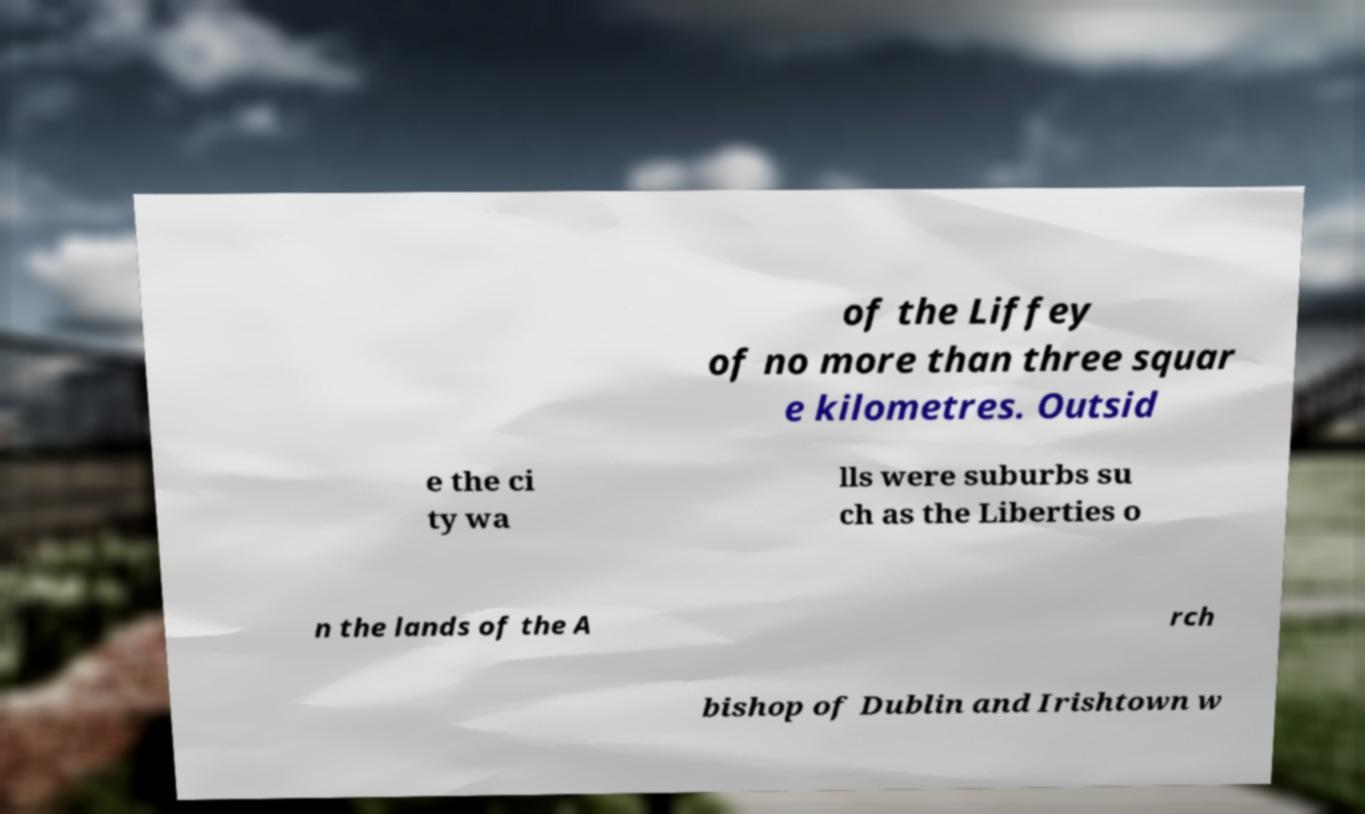I need the written content from this picture converted into text. Can you do that? of the Liffey of no more than three squar e kilometres. Outsid e the ci ty wa lls were suburbs su ch as the Liberties o n the lands of the A rch bishop of Dublin and Irishtown w 